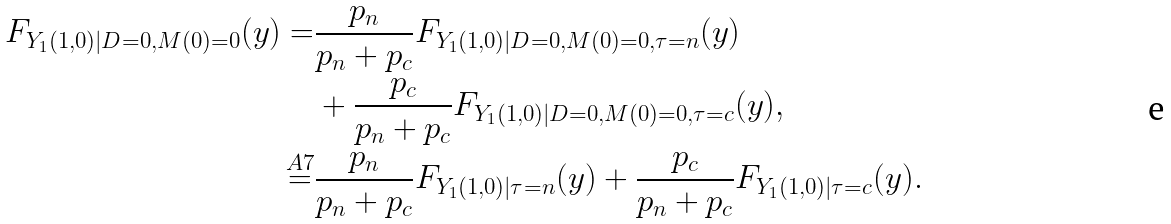<formula> <loc_0><loc_0><loc_500><loc_500>F _ { Y _ { 1 } ( 1 , 0 ) | D = 0 , M ( 0 ) = 0 } ( y ) = & \frac { p _ { n } } { p _ { n } + p _ { c } } F _ { Y _ { 1 } ( 1 , 0 ) | D = 0 , M ( 0 ) = 0 , \tau = n } ( y ) \\ & + \frac { p _ { c } } { p _ { n } + p _ { c } } F _ { Y _ { 1 } ( 1 , 0 ) | D = 0 , M ( 0 ) = 0 , \tau = c } ( y ) , \\ \stackrel { A 7 } { = } & \frac { p _ { n } } { p _ { n } + p _ { c } } F _ { Y _ { 1 } ( 1 , 0 ) | \tau = n } ( y ) + \frac { p _ { c } } { p _ { n } + p _ { c } } F _ { Y _ { 1 } ( 1 , 0 ) | \tau = c } ( y ) .</formula> 